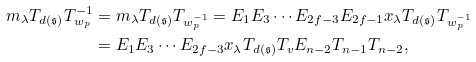Convert formula to latex. <formula><loc_0><loc_0><loc_500><loc_500>m _ { \lambda } T _ { d ( \mathfrak { s } ) } T _ { w _ { p } } ^ { - 1 } & = m _ { \lambda } T _ { d ( \mathfrak { s } ) } T _ { w _ { p } ^ { - 1 } } = E _ { 1 } E _ { 3 } \cdots E _ { 2 f - 3 } E _ { 2 f - 1 } x _ { \lambda } T _ { d ( \mathfrak { s } ) } T _ { w _ { p } ^ { - 1 } } \\ & = E _ { 1 } E _ { 3 } \cdots E _ { 2 f - 3 } x _ { \lambda } T _ { d ( \mathfrak { s } ) } T _ { v } E _ { n - 2 } T _ { n - 1 } T _ { n - 2 } ,</formula> 